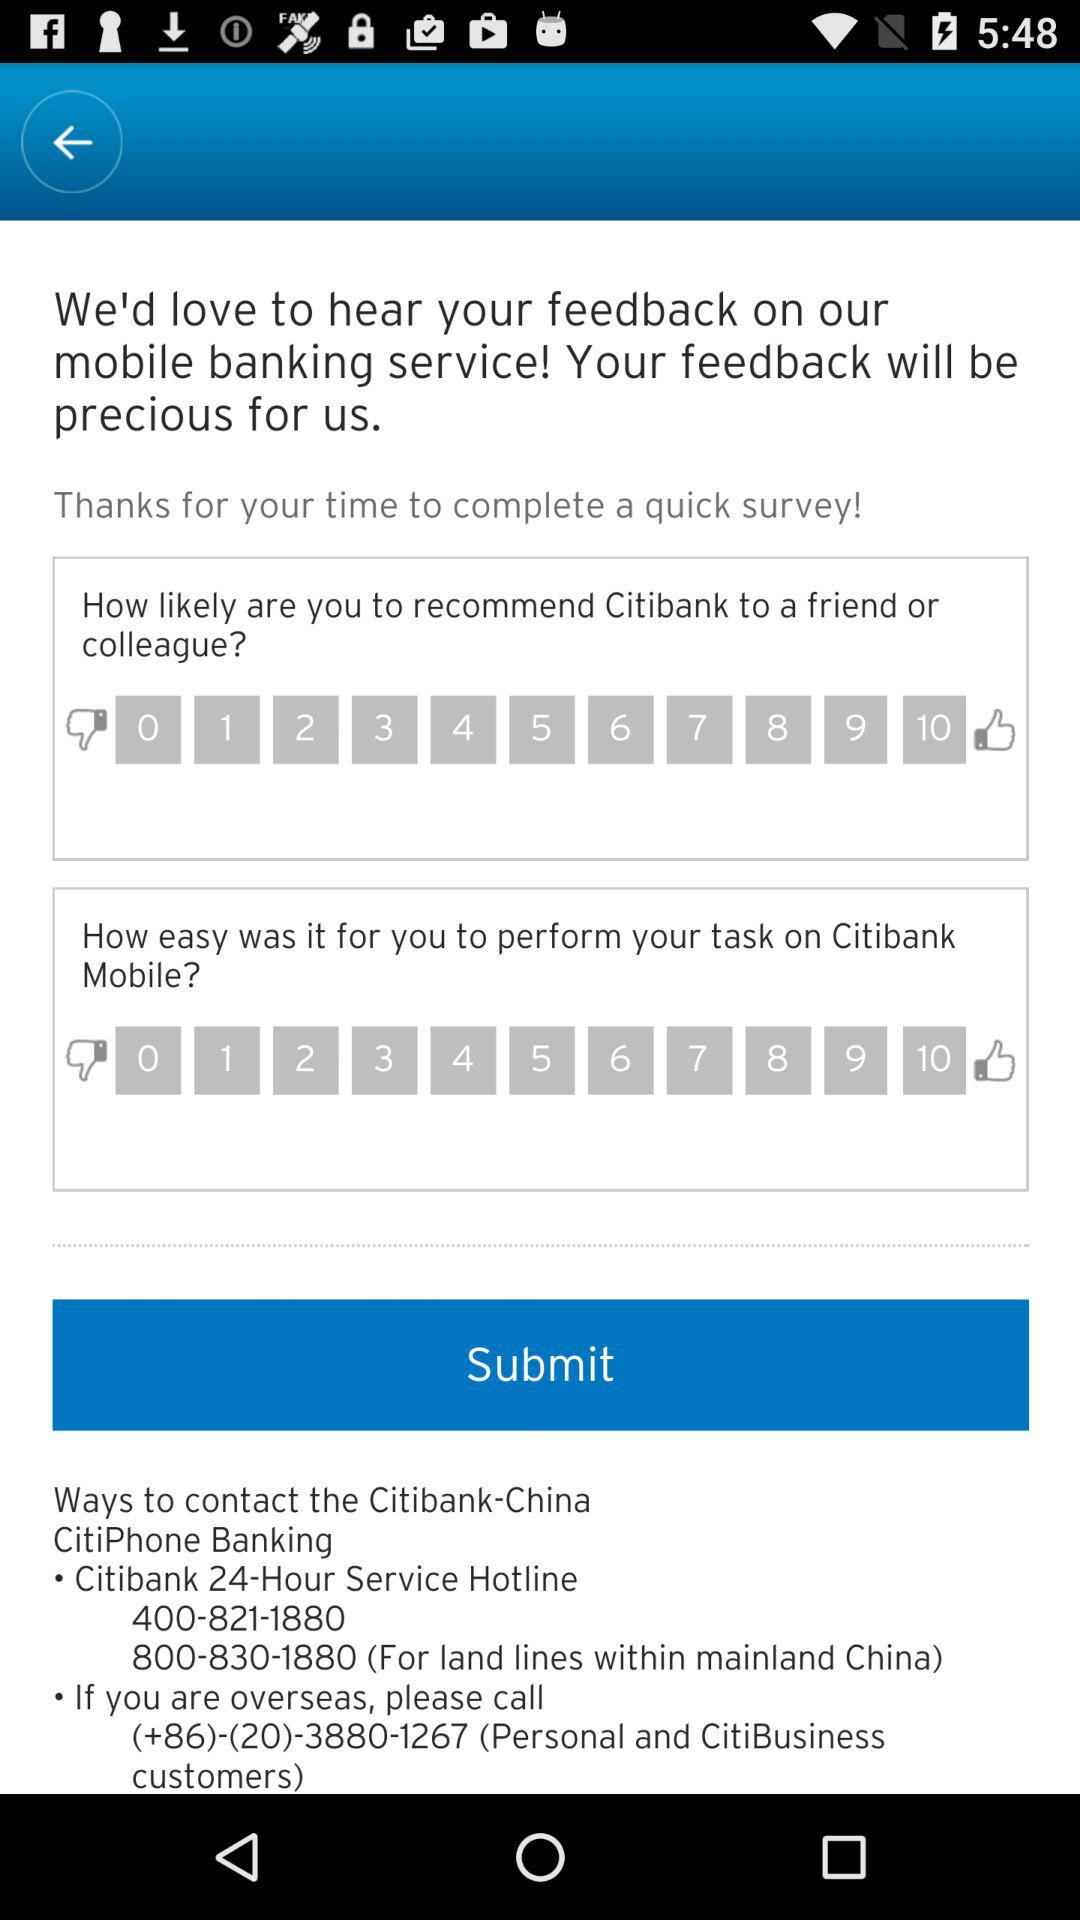What is the contact number for the service hotline? The contact number is 400-821-1880. 